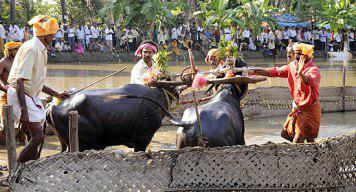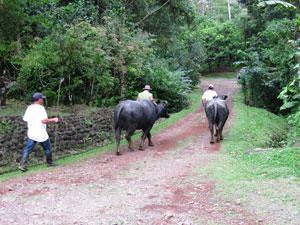The first image is the image on the left, the second image is the image on the right. Assess this claim about the two images: "In the left image, a man in a colored head wrap is standing behind two dark oxen and holding out a stick.". Correct or not? Answer yes or no. Yes. 